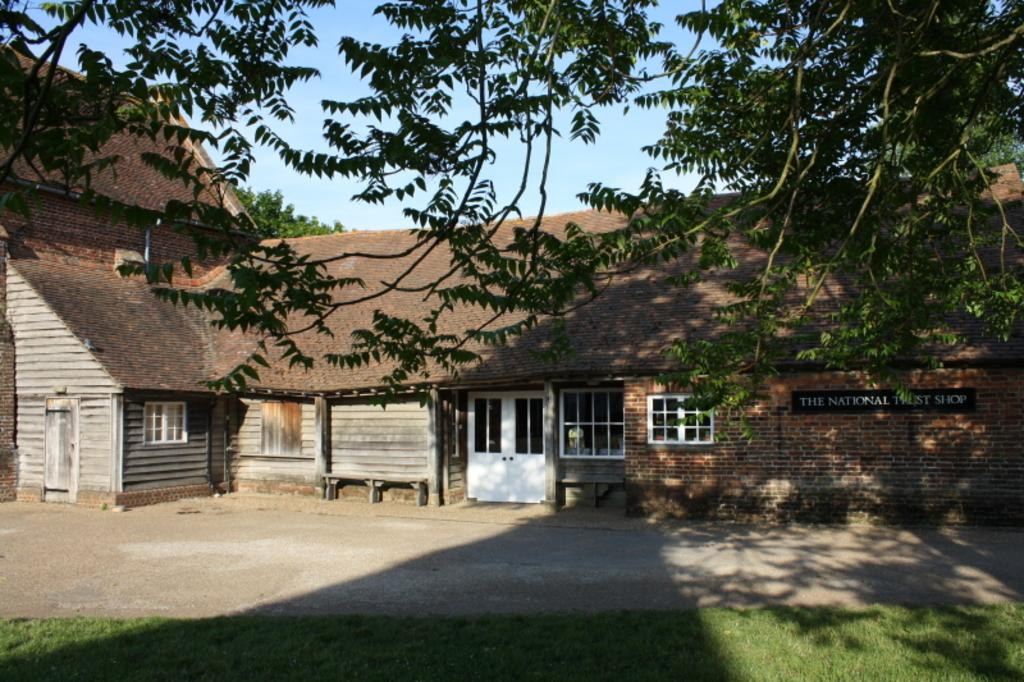What type of structure is visible in the image? There is a house in the image. What features can be seen on the house? The house has windows and doors. What additional information is provided on the board in the image? There is a board with text in the image. What type of natural environment surrounds the house? There are trees, grass, and a footpath in the image. What can be seen in the sky in the image? The sky is visible in the image. What type of wheel is visible on the house in the image? There is no wheel visible on the house in the image. What behavior can be observed in the trees in the image? There is no behavior to observe in the trees in the image; they are stationary. 